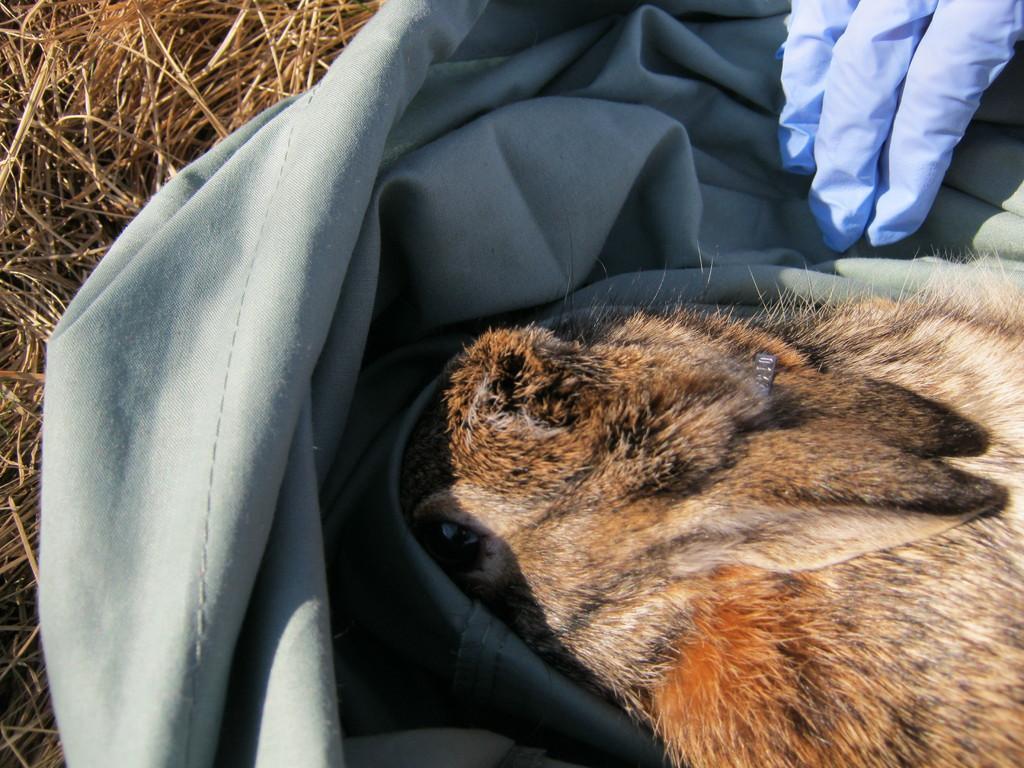Please provide a concise description of this image. The picture consists of rabbit, bag, person hand and dry grass. 